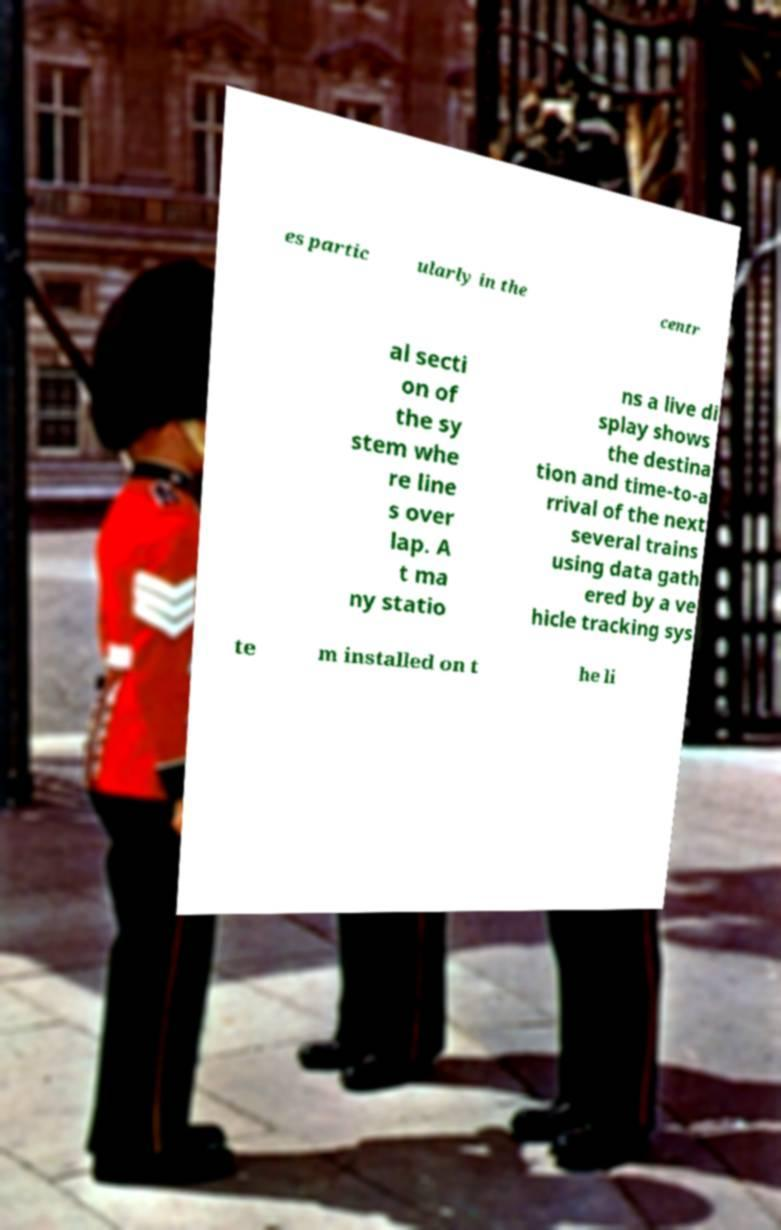Could you extract and type out the text from this image? es partic ularly in the centr al secti on of the sy stem whe re line s over lap. A t ma ny statio ns a live di splay shows the destina tion and time-to-a rrival of the next several trains using data gath ered by a ve hicle tracking sys te m installed on t he li 